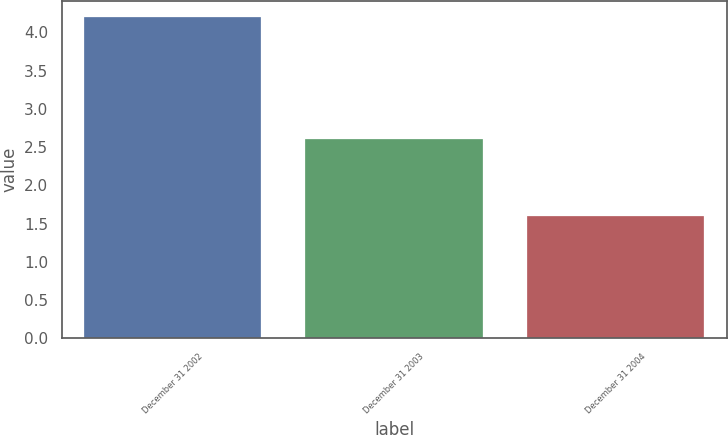Convert chart to OTSL. <chart><loc_0><loc_0><loc_500><loc_500><bar_chart><fcel>December 31 2002<fcel>December 31 2003<fcel>December 31 2004<nl><fcel>4.2<fcel>2.6<fcel>1.6<nl></chart> 